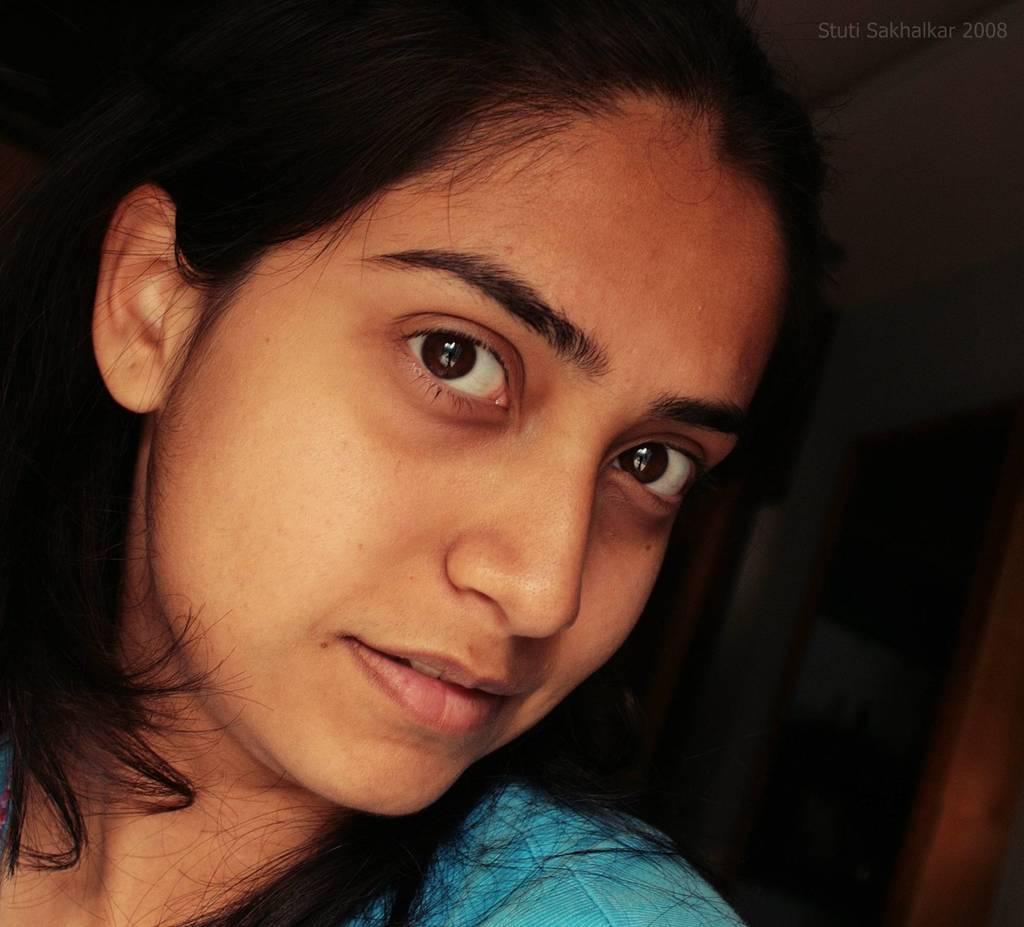In one or two sentences, can you explain what this image depicts? In this picture we can see a woman smiling and in the background we can see the wall, door and it is dark. 